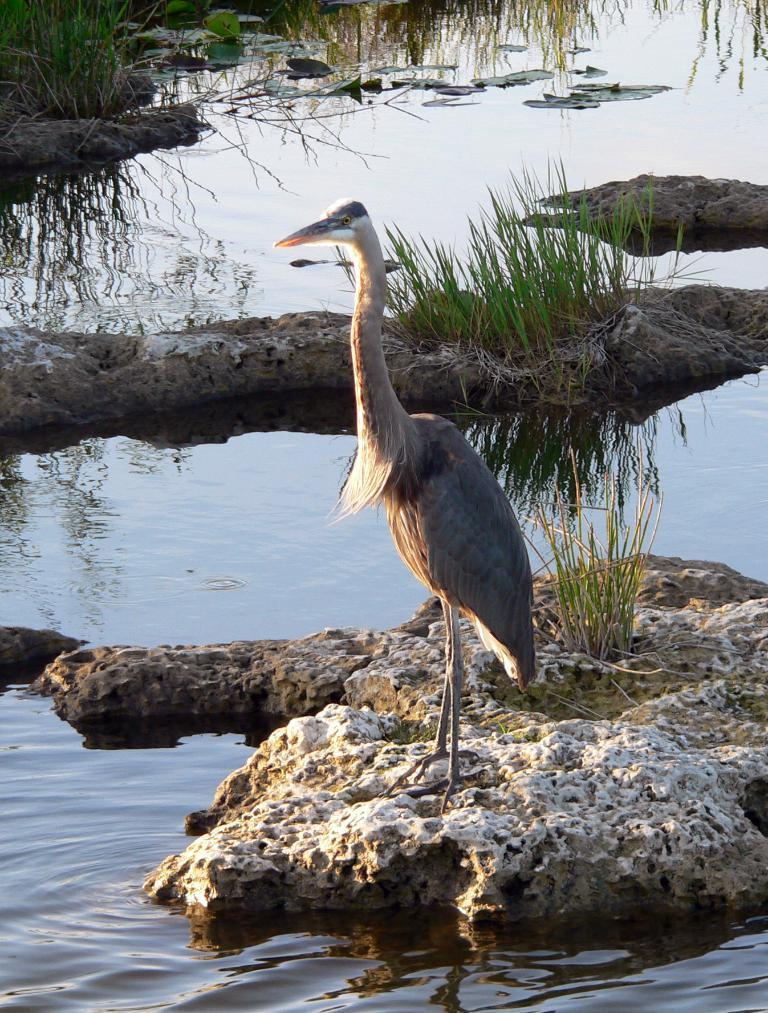In one or two sentences, can you explain what this image depicts? In the center of the image there is a bird on the stone. At the bottom of the image there is water. In the background of the image there is grass. 